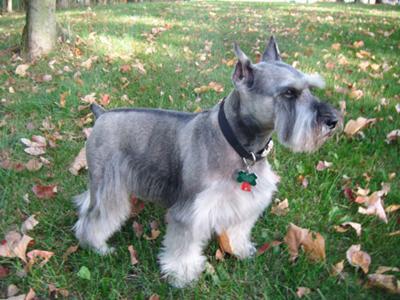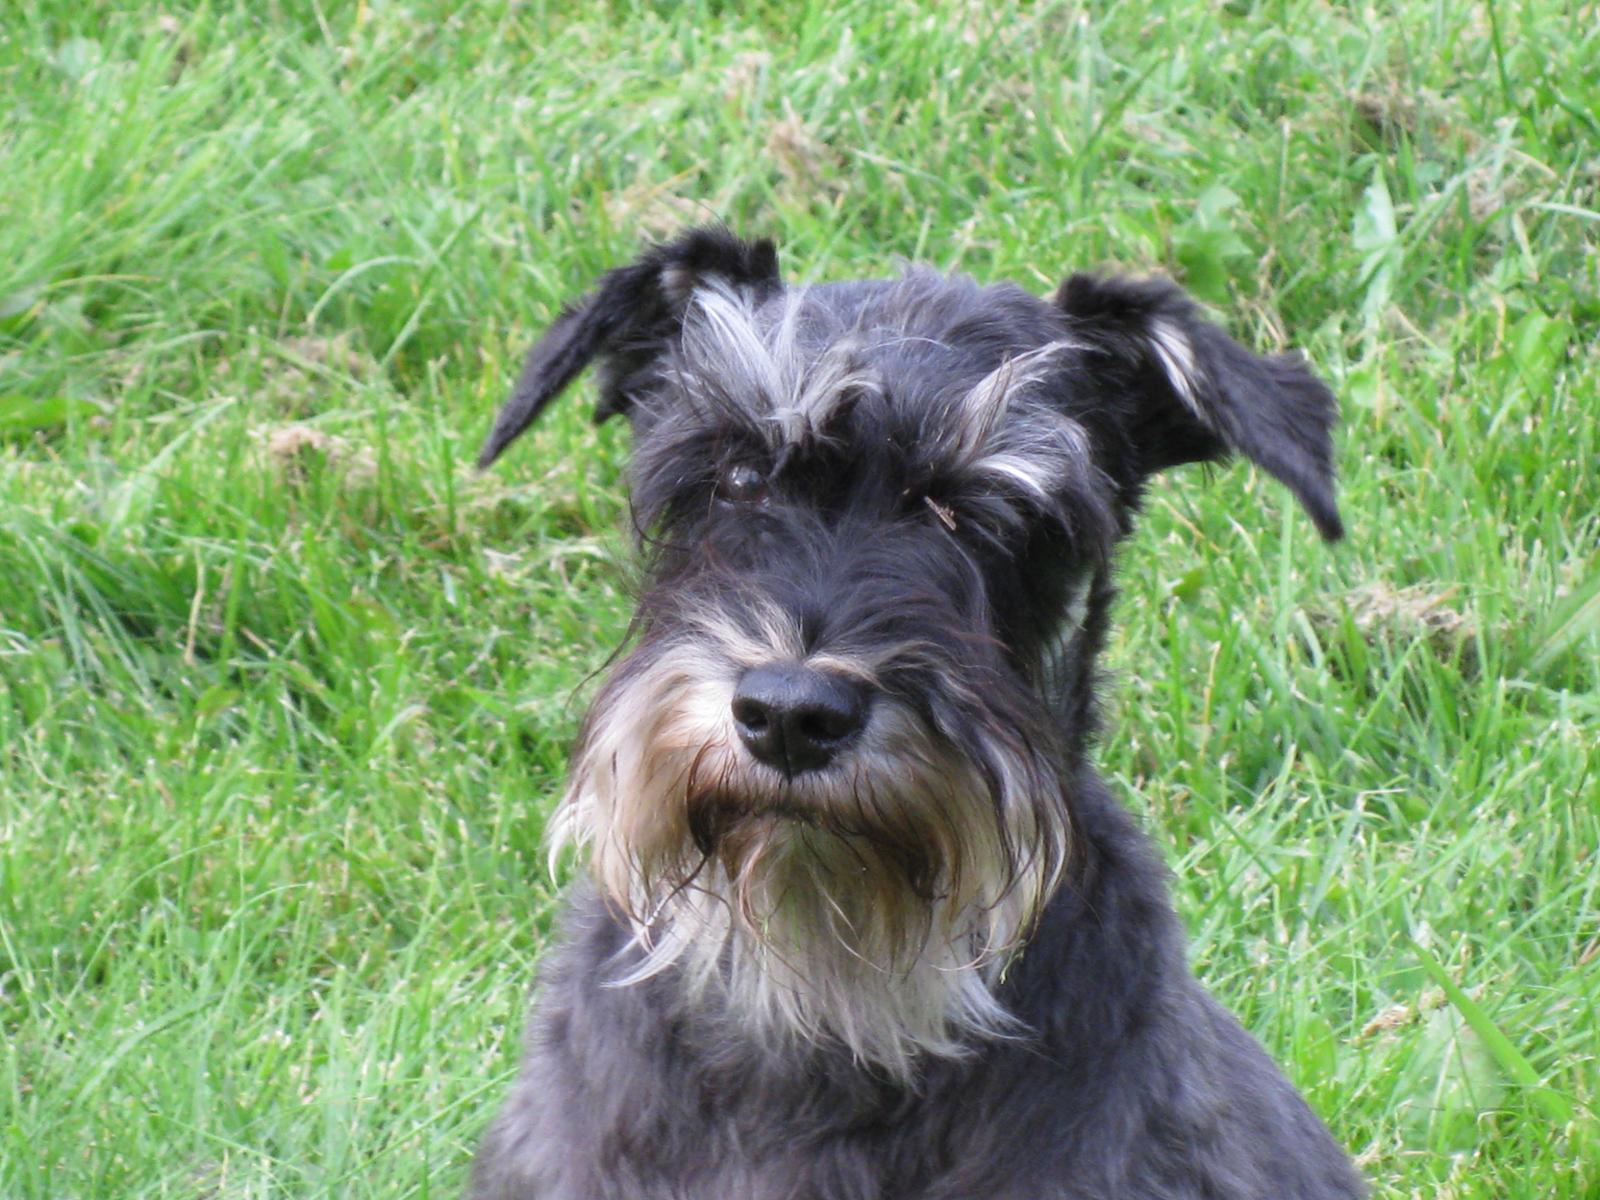The first image is the image on the left, the second image is the image on the right. Considering the images on both sides, is "There are at most two dogs." valid? Answer yes or no. Yes. The first image is the image on the left, the second image is the image on the right. Assess this claim about the two images: "The right image contains no more than one dog.". Correct or not? Answer yes or no. Yes. 